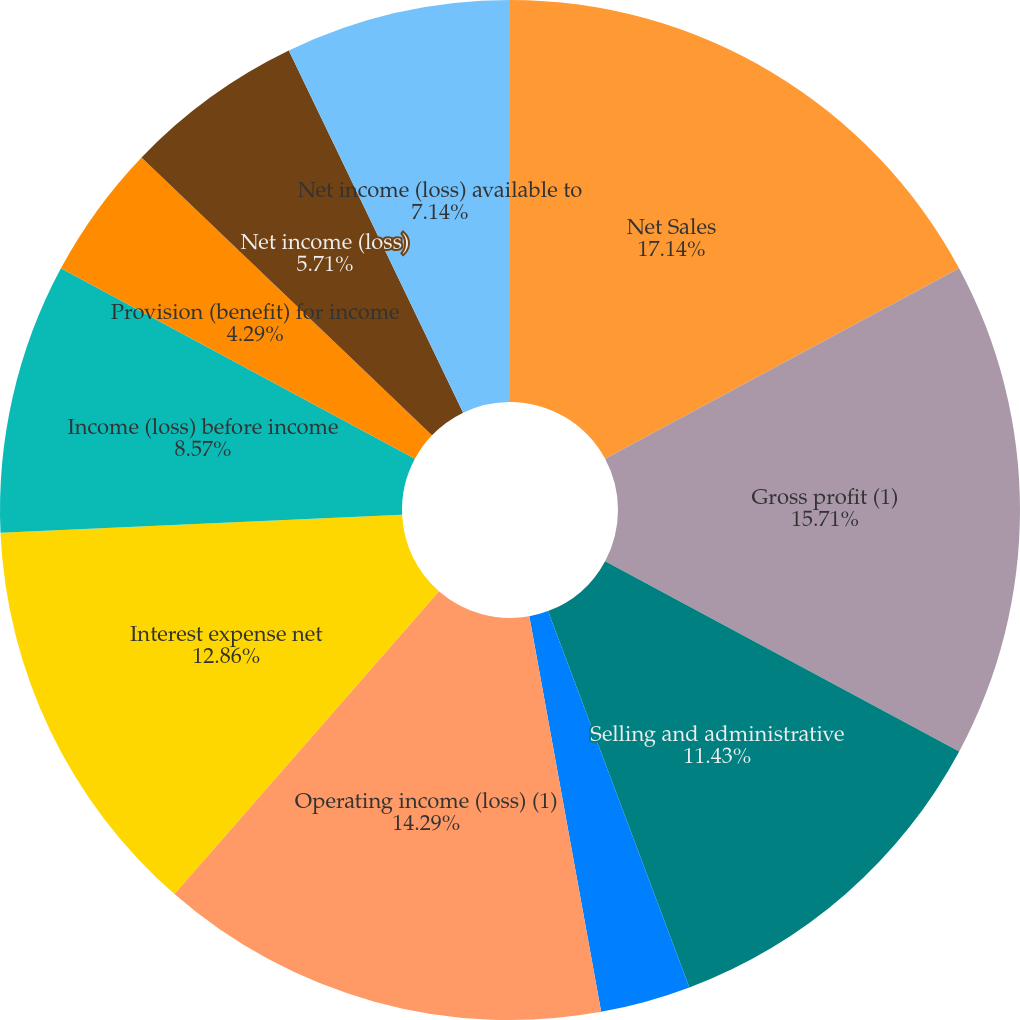Convert chart. <chart><loc_0><loc_0><loc_500><loc_500><pie_chart><fcel>Net Sales<fcel>Gross profit (1)<fcel>Selling and administrative<fcel>Amortization of intangibles<fcel>Operating income (loss) (1)<fcel>Interest expense net<fcel>Income (loss) before income<fcel>Provision (benefit) for income<fcel>Net income (loss)<fcel>Net income (loss) available to<nl><fcel>17.14%<fcel>15.71%<fcel>11.43%<fcel>2.86%<fcel>14.29%<fcel>12.86%<fcel>8.57%<fcel>4.29%<fcel>5.71%<fcel>7.14%<nl></chart> 